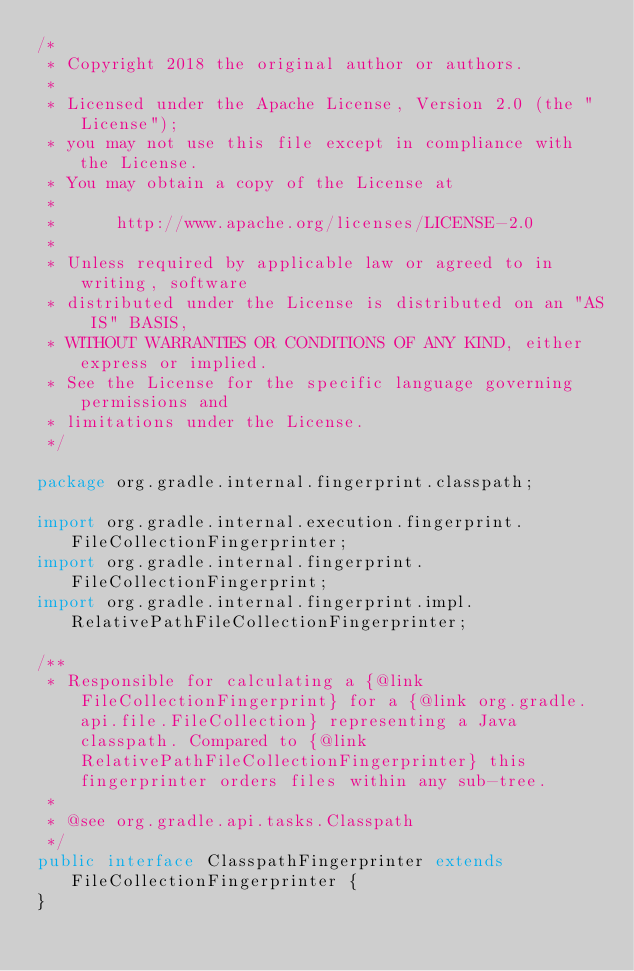<code> <loc_0><loc_0><loc_500><loc_500><_Java_>/*
 * Copyright 2018 the original author or authors.
 *
 * Licensed under the Apache License, Version 2.0 (the "License");
 * you may not use this file except in compliance with the License.
 * You may obtain a copy of the License at
 *
 *      http://www.apache.org/licenses/LICENSE-2.0
 *
 * Unless required by applicable law or agreed to in writing, software
 * distributed under the License is distributed on an "AS IS" BASIS,
 * WITHOUT WARRANTIES OR CONDITIONS OF ANY KIND, either express or implied.
 * See the License for the specific language governing permissions and
 * limitations under the License.
 */

package org.gradle.internal.fingerprint.classpath;

import org.gradle.internal.execution.fingerprint.FileCollectionFingerprinter;
import org.gradle.internal.fingerprint.FileCollectionFingerprint;
import org.gradle.internal.fingerprint.impl.RelativePathFileCollectionFingerprinter;

/**
 * Responsible for calculating a {@link FileCollectionFingerprint} for a {@link org.gradle.api.file.FileCollection} representing a Java classpath. Compared to {@link RelativePathFileCollectionFingerprinter} this fingerprinter orders files within any sub-tree.
 *
 * @see org.gradle.api.tasks.Classpath
 */
public interface ClasspathFingerprinter extends FileCollectionFingerprinter {
}
</code> 